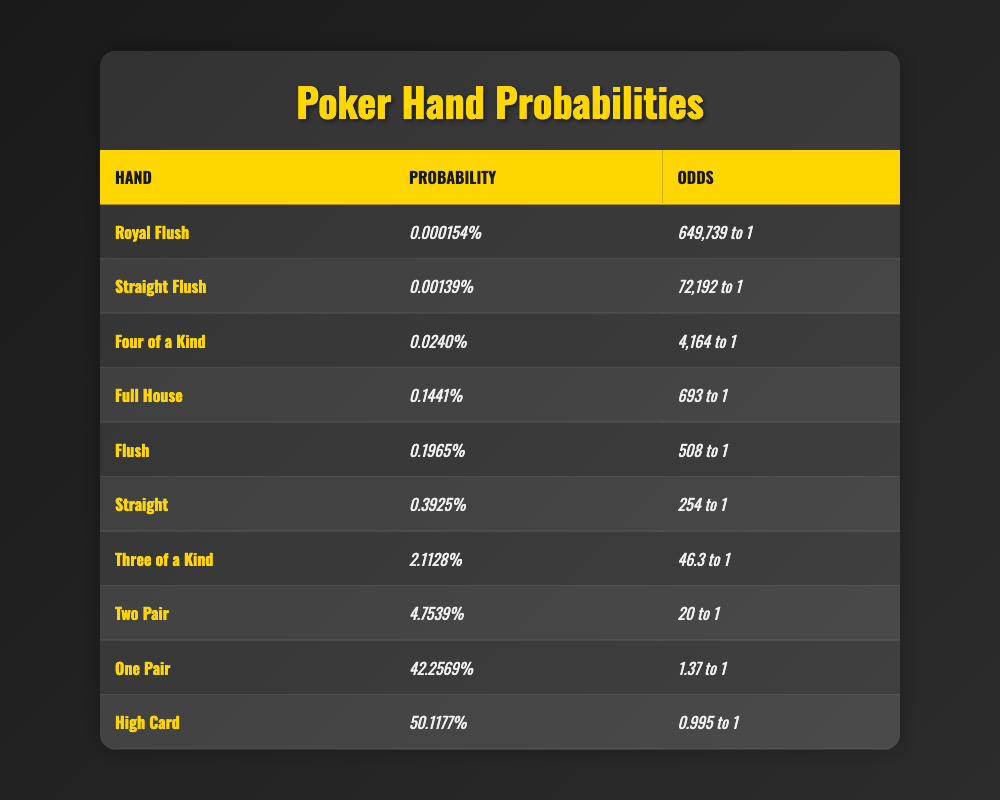What is the probability of getting a Royal Flush? The table shows that the probability of getting a Royal Flush is listed as 0.000154%.
Answer: 0.000154% How many times more likely is it to get One Pair than a Royal Flush? The probability of One Pair is 42.2569% and for Royal Flush it's 0.000154%. To find how many times more likely, divide 42.2569% by 0.000154%, which equals approximately 274,248 times more likely.
Answer: 274,248 times Is it true that having a High Card is more likely than getting a Flush? The table states that the probability of a High Card is 50.1177%, while the probability of a Flush is 0.1965%. Since 50.1177% is greater than 0.1965%, it is true that a High Card is more likely than a Flush.
Answer: Yes What is the combined probability of getting a Full House or Four of a Kind? The probability of Full House is 0.1441% and for Four of a Kind is 0.0240%. Adding these gives 0.1441% + 0.0240% = 0.1681%.
Answer: 0.1681% What is the odds ratio of getting Three of a Kind compared to a Straight? The odds for Three of a Kind is 46.3 to 1 and for Straight is 254 to 1. To find the odds ratio, divide 46.3 by 254, which gives approximately 0.1823.
Answer: 0.1823 Which hand has the lowest probability listed in the table? By reviewing the probabilities, Royal Flush has the lowest probability at 0.000154%.
Answer: Royal Flush How much more likely is it to get Two Pair than a Straight Flush? The probability of Two Pair is 4.7539% and for Straight Flush is 0.00139%. Hence, 4.7539% / 0.00139% gives approximately 3,415 times more likely.
Answer: 3,415 times What percentage of hands can be classified as either One Pair or Two Pair? The probabilities of One Pair and Two Pair are 42.2569% and 4.7539%, respectively. Adding them yields 42.2569% + 4.7539% = 47.0108%.
Answer: 47.0108% According to the table, which hand has the best odds? The hand with the best odds is One Pair, which has odds of 1.37 to 1.
Answer: One Pair If you were to draw 100 hands, how many can you expect to have a High Card? The probability of a High Card is 50.1177%. Thus, in 100 hands, you can expect around 50 hands to be a High Card (50.1177% of 100).
Answer: 50 hands 